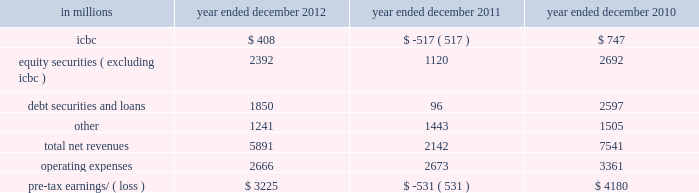Management 2019s discussion and analysis net revenues in equities were $ 8.26 billion for 2011 , 2% ( 2 % ) higher than 2010 .
During 2011 , average volatility levels increased and equity prices in europe and asia declined significantly , particularly during the third quarter .
The increase in net revenues reflected higher commissions and fees , primarily due to higher market volumes , particularly during the third quarter of 2011 .
In addition , net revenues in securities services increased compared with 2010 , reflecting the impact of higher average customer balances .
Equities client execution net revenues were lower than 2010 , primarily reflecting significantly lower net revenues in shares .
The net gain attributable to the impact of changes in our own credit spreads on borrowings for which the fair value option was elected was $ 596 million ( $ 399 million and $ 197 million related to fixed income , currency and commodities client execution and equities client execution , respectively ) for 2011 , compared with a net gain of $ 198 million ( $ 188 million and $ 10 million related to fixed income , currency and commodities client execution and equities client execution , respectively ) for 2010 .
Institutional client services operated in an environment generally characterized by increased concerns regarding the weakened state of global economies , including heightened european sovereign debt risk , and its impact on the european banking system and global financial institutions .
These conditions also impacted expectations for economic prospects in the united states and were reflected in equity and debt markets more broadly .
In addition , the downgrade in credit ratings of the u.s .
Government and federal agencies and many financial institutions during the second half of 2011 contributed to further uncertainty in the markets .
These concerns , as well as other broad market concerns , such as uncertainty over financial regulatory reform , continued to have a negative impact on our net revenues during 2011 .
Operating expenses were $ 12.84 billion for 2011 , 14% ( 14 % ) lower than 2010 , due to decreased compensation and benefits expenses , primarily resulting from lower net revenues , lower net provisions for litigation and regulatory proceedings ( 2010 included $ 550 million related to a settlement with the sec ) , the impact of the u.k .
Bank payroll tax during 2010 , as well as an impairment of our nyse dmm rights of $ 305 million during 2010 .
These decreases were partially offset by higher brokerage , clearing , exchange and distribution fees , principally reflecting higher transaction volumes in equities .
Pre-tax earnings were $ 4.44 billion in 2011 , 35% ( 35 % ) lower than 2010 .
Investing & lending investing & lending includes our investing activities and the origination of loans to provide financing to clients .
These investments and loans are typically longer-term in nature .
We make investments , directly and indirectly through funds that we manage , in debt securities and loans , public and private equity securities , real estate , consolidated investment entities and power generation facilities .
The table below presents the operating results of our investing & lending segment. .
2012 versus 2011 .
Net revenues in investing & lending were $ 5.89 billion and $ 2.14 billion for 2012 and 2011 , respectively .
During 2012 , investing & lending net revenues were positively impacted by tighter credit spreads and an increase in global equity prices .
Results for 2012 included a gain of $ 408 million from our investment in the ordinary shares of icbc , net gains of $ 2.39 billion from other investments in equities , primarily in private equities , net gains and net interest income of $ 1.85 billion from debt securities and loans , and other net revenues of $ 1.24 billion , principally related to our consolidated investment entities .
If equity markets decline or credit spreads widen , net revenues in investing & lending would likely be negatively impacted .
Operating expenses were $ 2.67 billion for 2012 , essentially unchanged compared with 2011 .
Pre-tax earnings were $ 3.23 billion in 2012 , compared with a pre-tax loss of $ 531 million in 2011 .
Goldman sachs 2012 annual report 55 .
Between the years ended december 2011 and 2012 , what was the decrease in millions in icbc? 
Computations: (747 - -517)
Answer: 1264.0. 